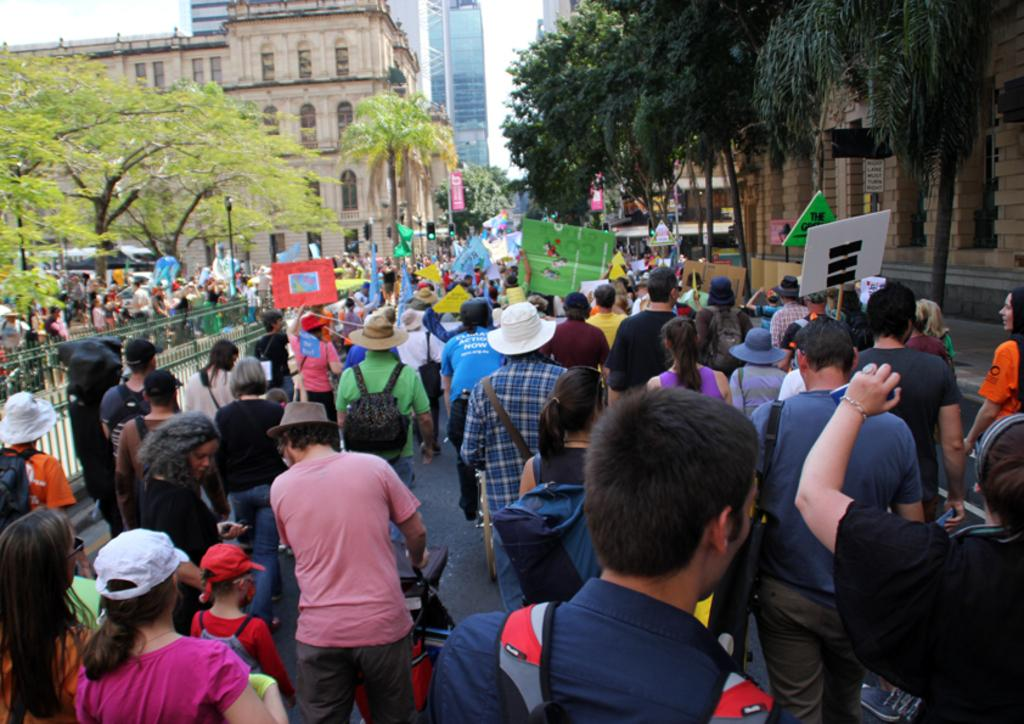What is happening on the roads in the image? There are many people on the roads in the image. What are some of the people holding in their hands? Some people are holding boards in their hands. What type of vegetation can be seen on the sides of the roads? There are trees on the right and left sides of the image. What type of structures can be seen in the image? There are buildings visible in the image. What type of food is being served at the organization's event in the image? There is no mention of an organization or an event in the image, nor is there any indication of food being served. 